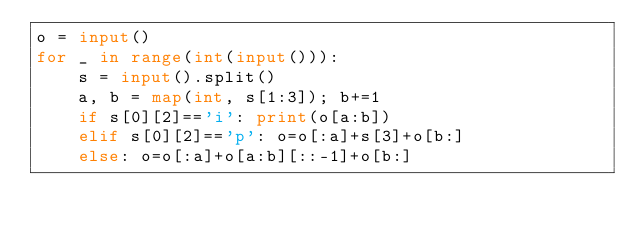<code> <loc_0><loc_0><loc_500><loc_500><_Python_>o = input()
for _ in range(int(input())):
    s = input().split()
    a, b = map(int, s[1:3]); b+=1
    if s[0][2]=='i': print(o[a:b])
    elif s[0][2]=='p': o=o[:a]+s[3]+o[b:]
    else: o=o[:a]+o[a:b][::-1]+o[b:]
</code> 